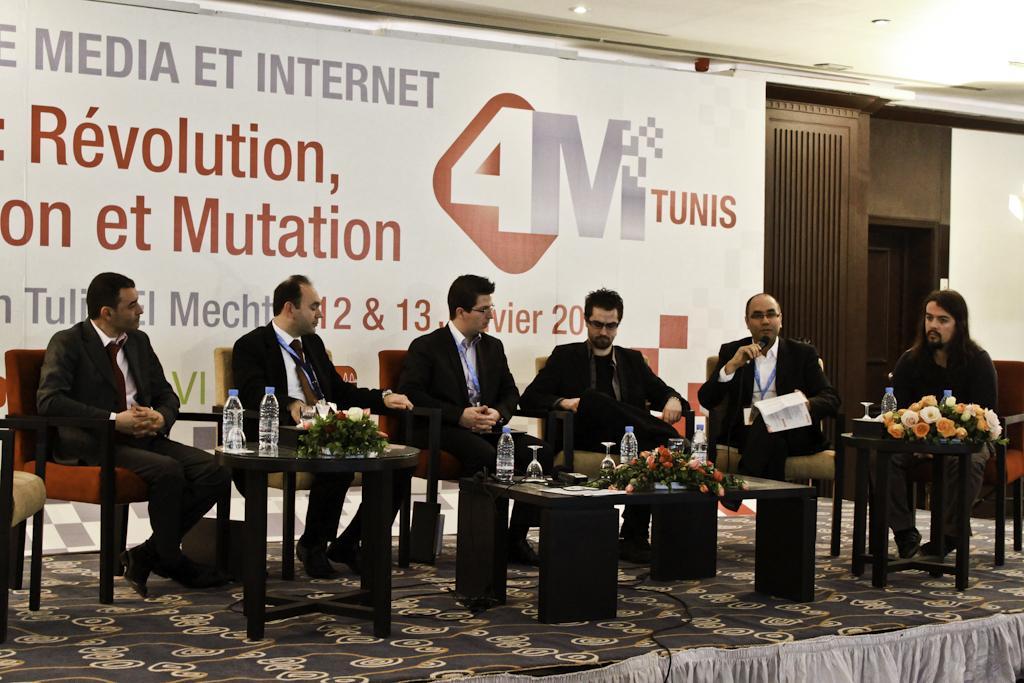Please provide a concise description of this image. This image consists of a person sitting on a chair on the stage. In the background there is a board. The person at the right side holding a mic in his hand is speaking. In the front there are table. On the table there are flowers, bottles. 